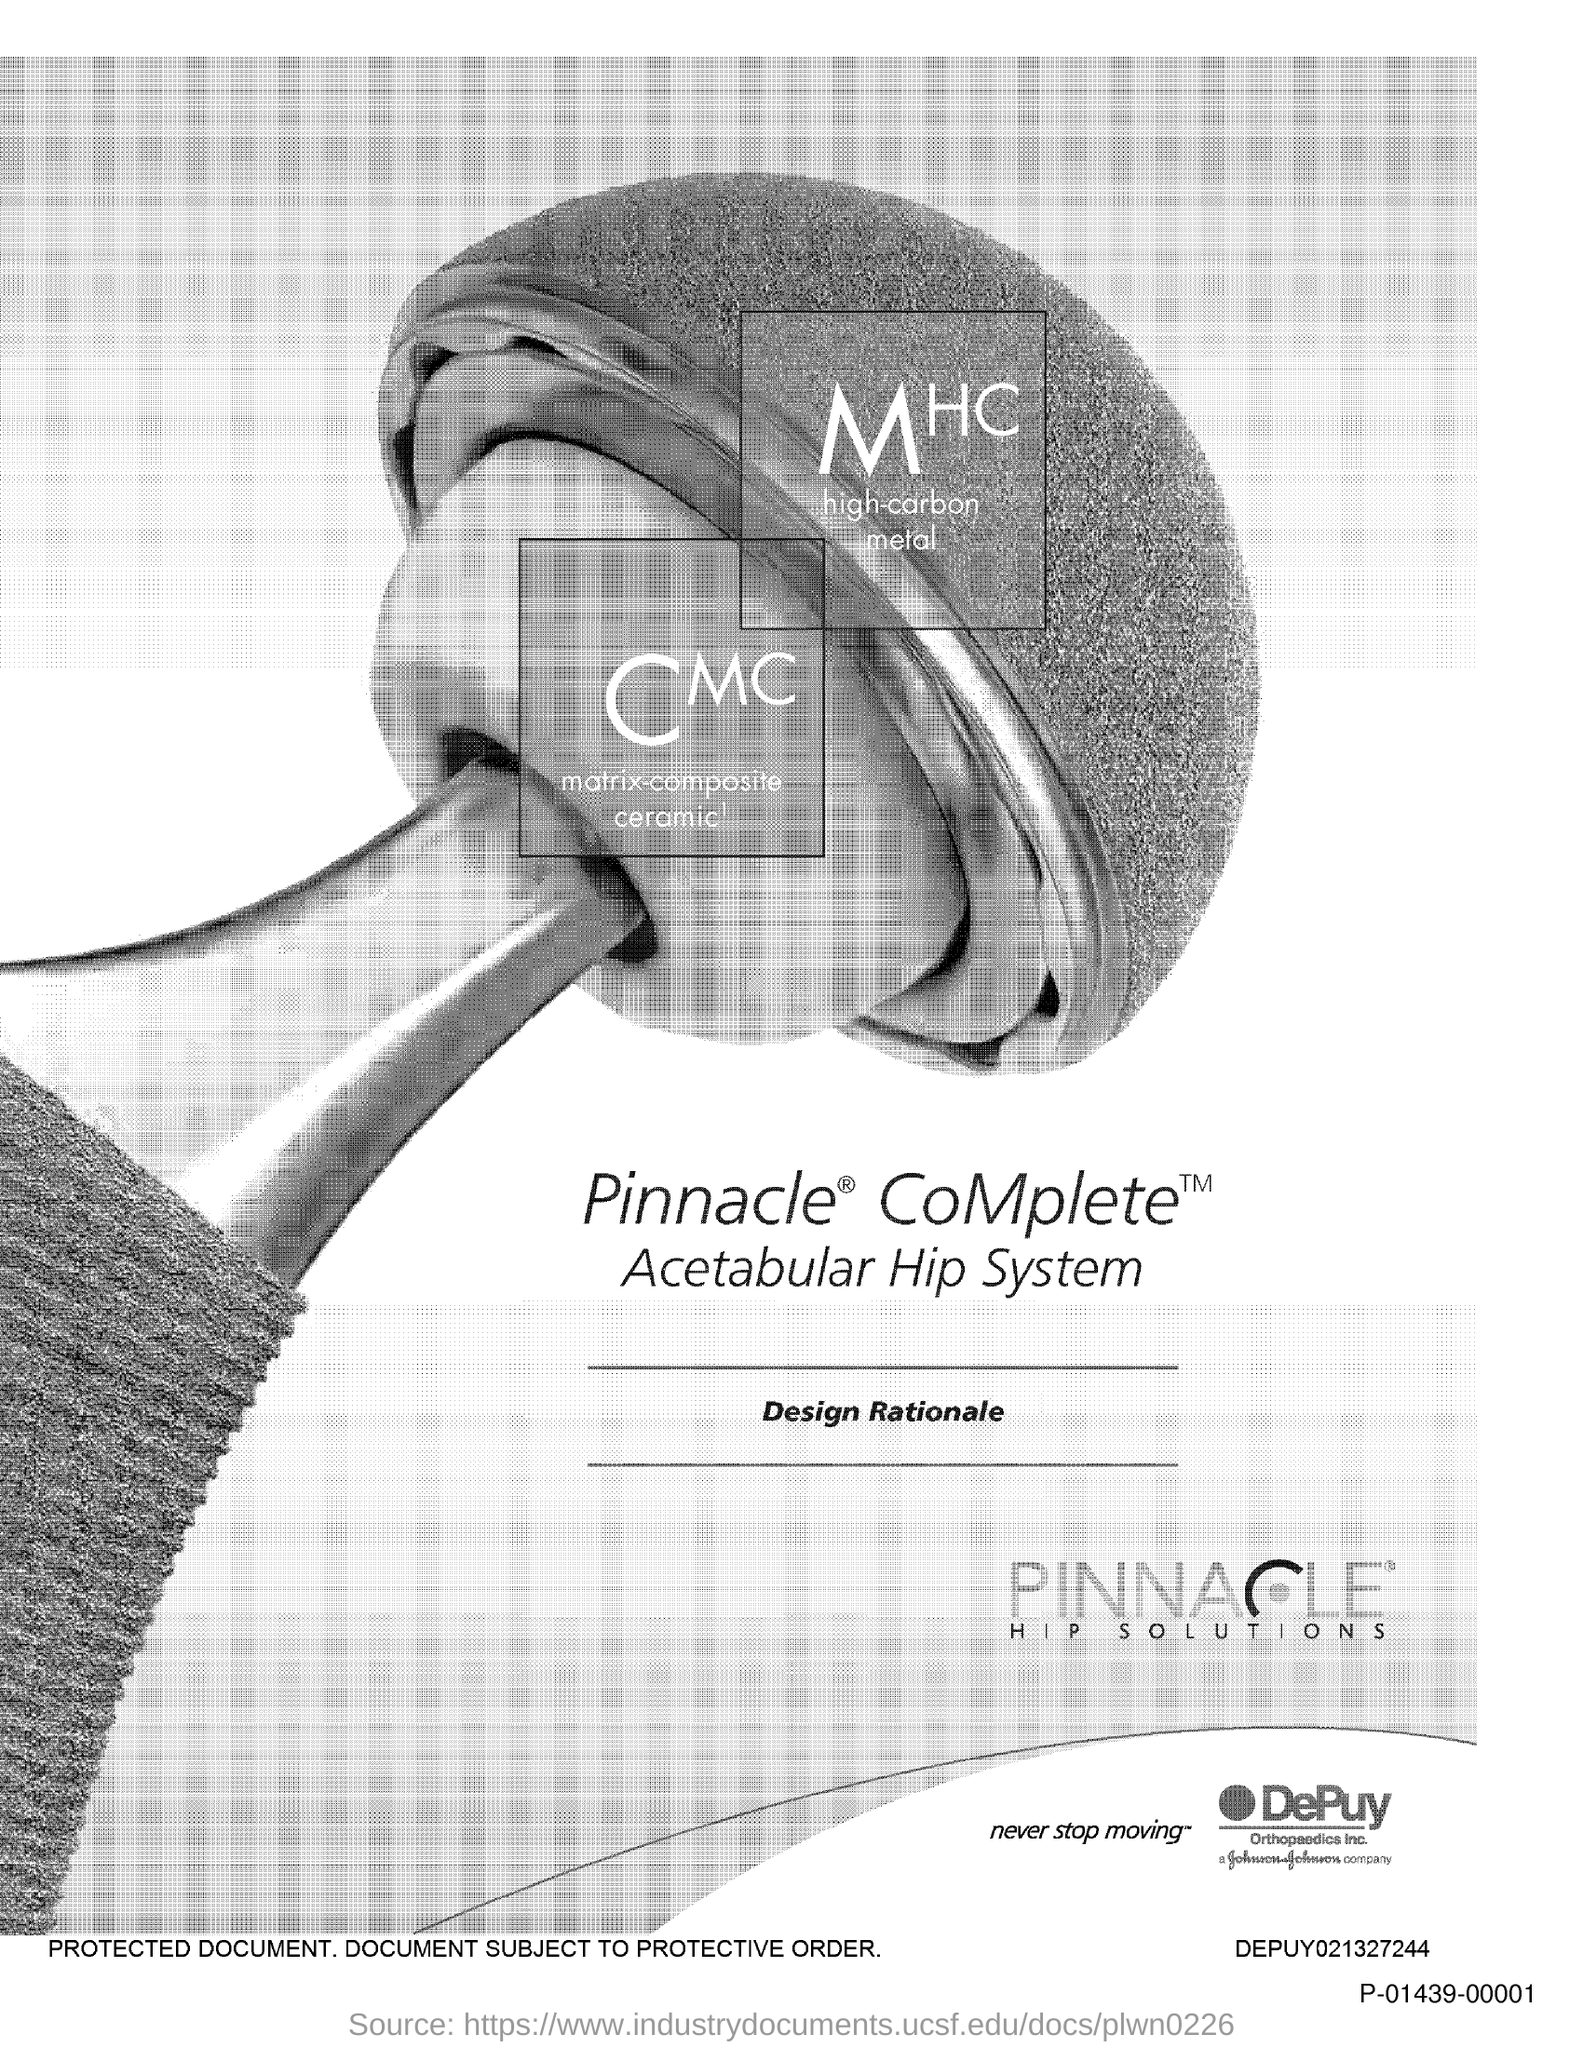Highlight a few significant elements in this photo. The text written between the two lines is 'Design Rationale.' 